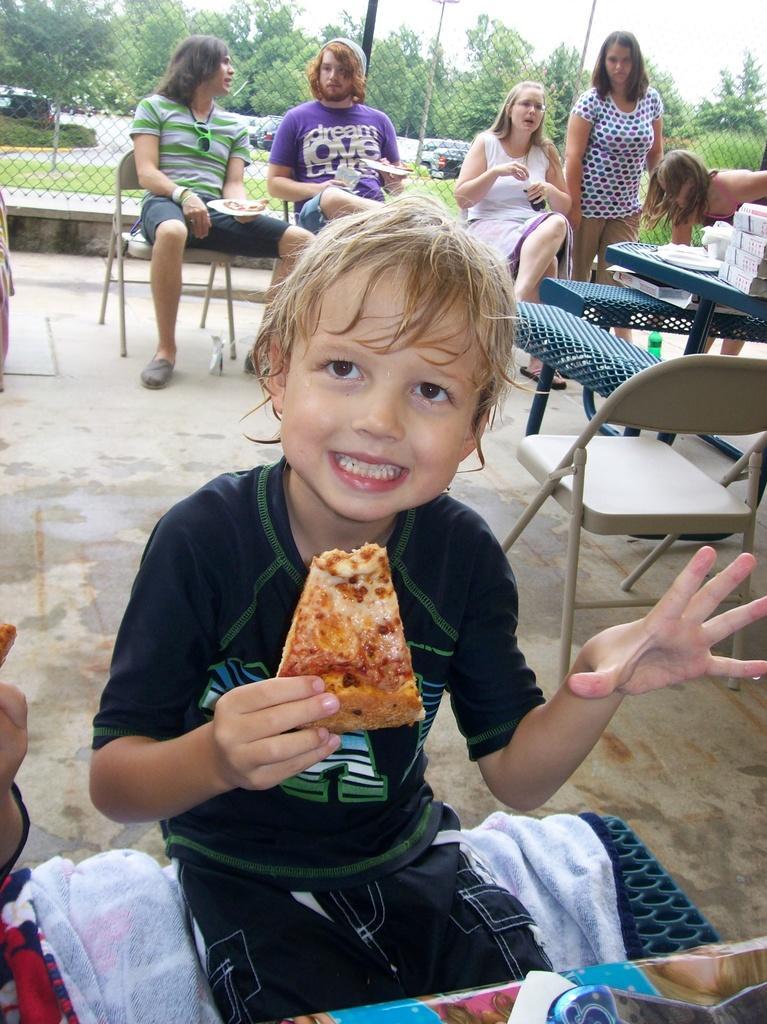Could you give a brief overview of what you see in this image? In this image we can see a child sitting on the clothes holding a pizza. On the backside we can see some people sitting on the chairs holding the plates and a bottle. We can also see some people standing and some objects placed on the table. We can also see some grass, plants, poles, a metal fence, a group of trees and the sky which looks cloudy. On the left bottom we can see the hand of a person. 